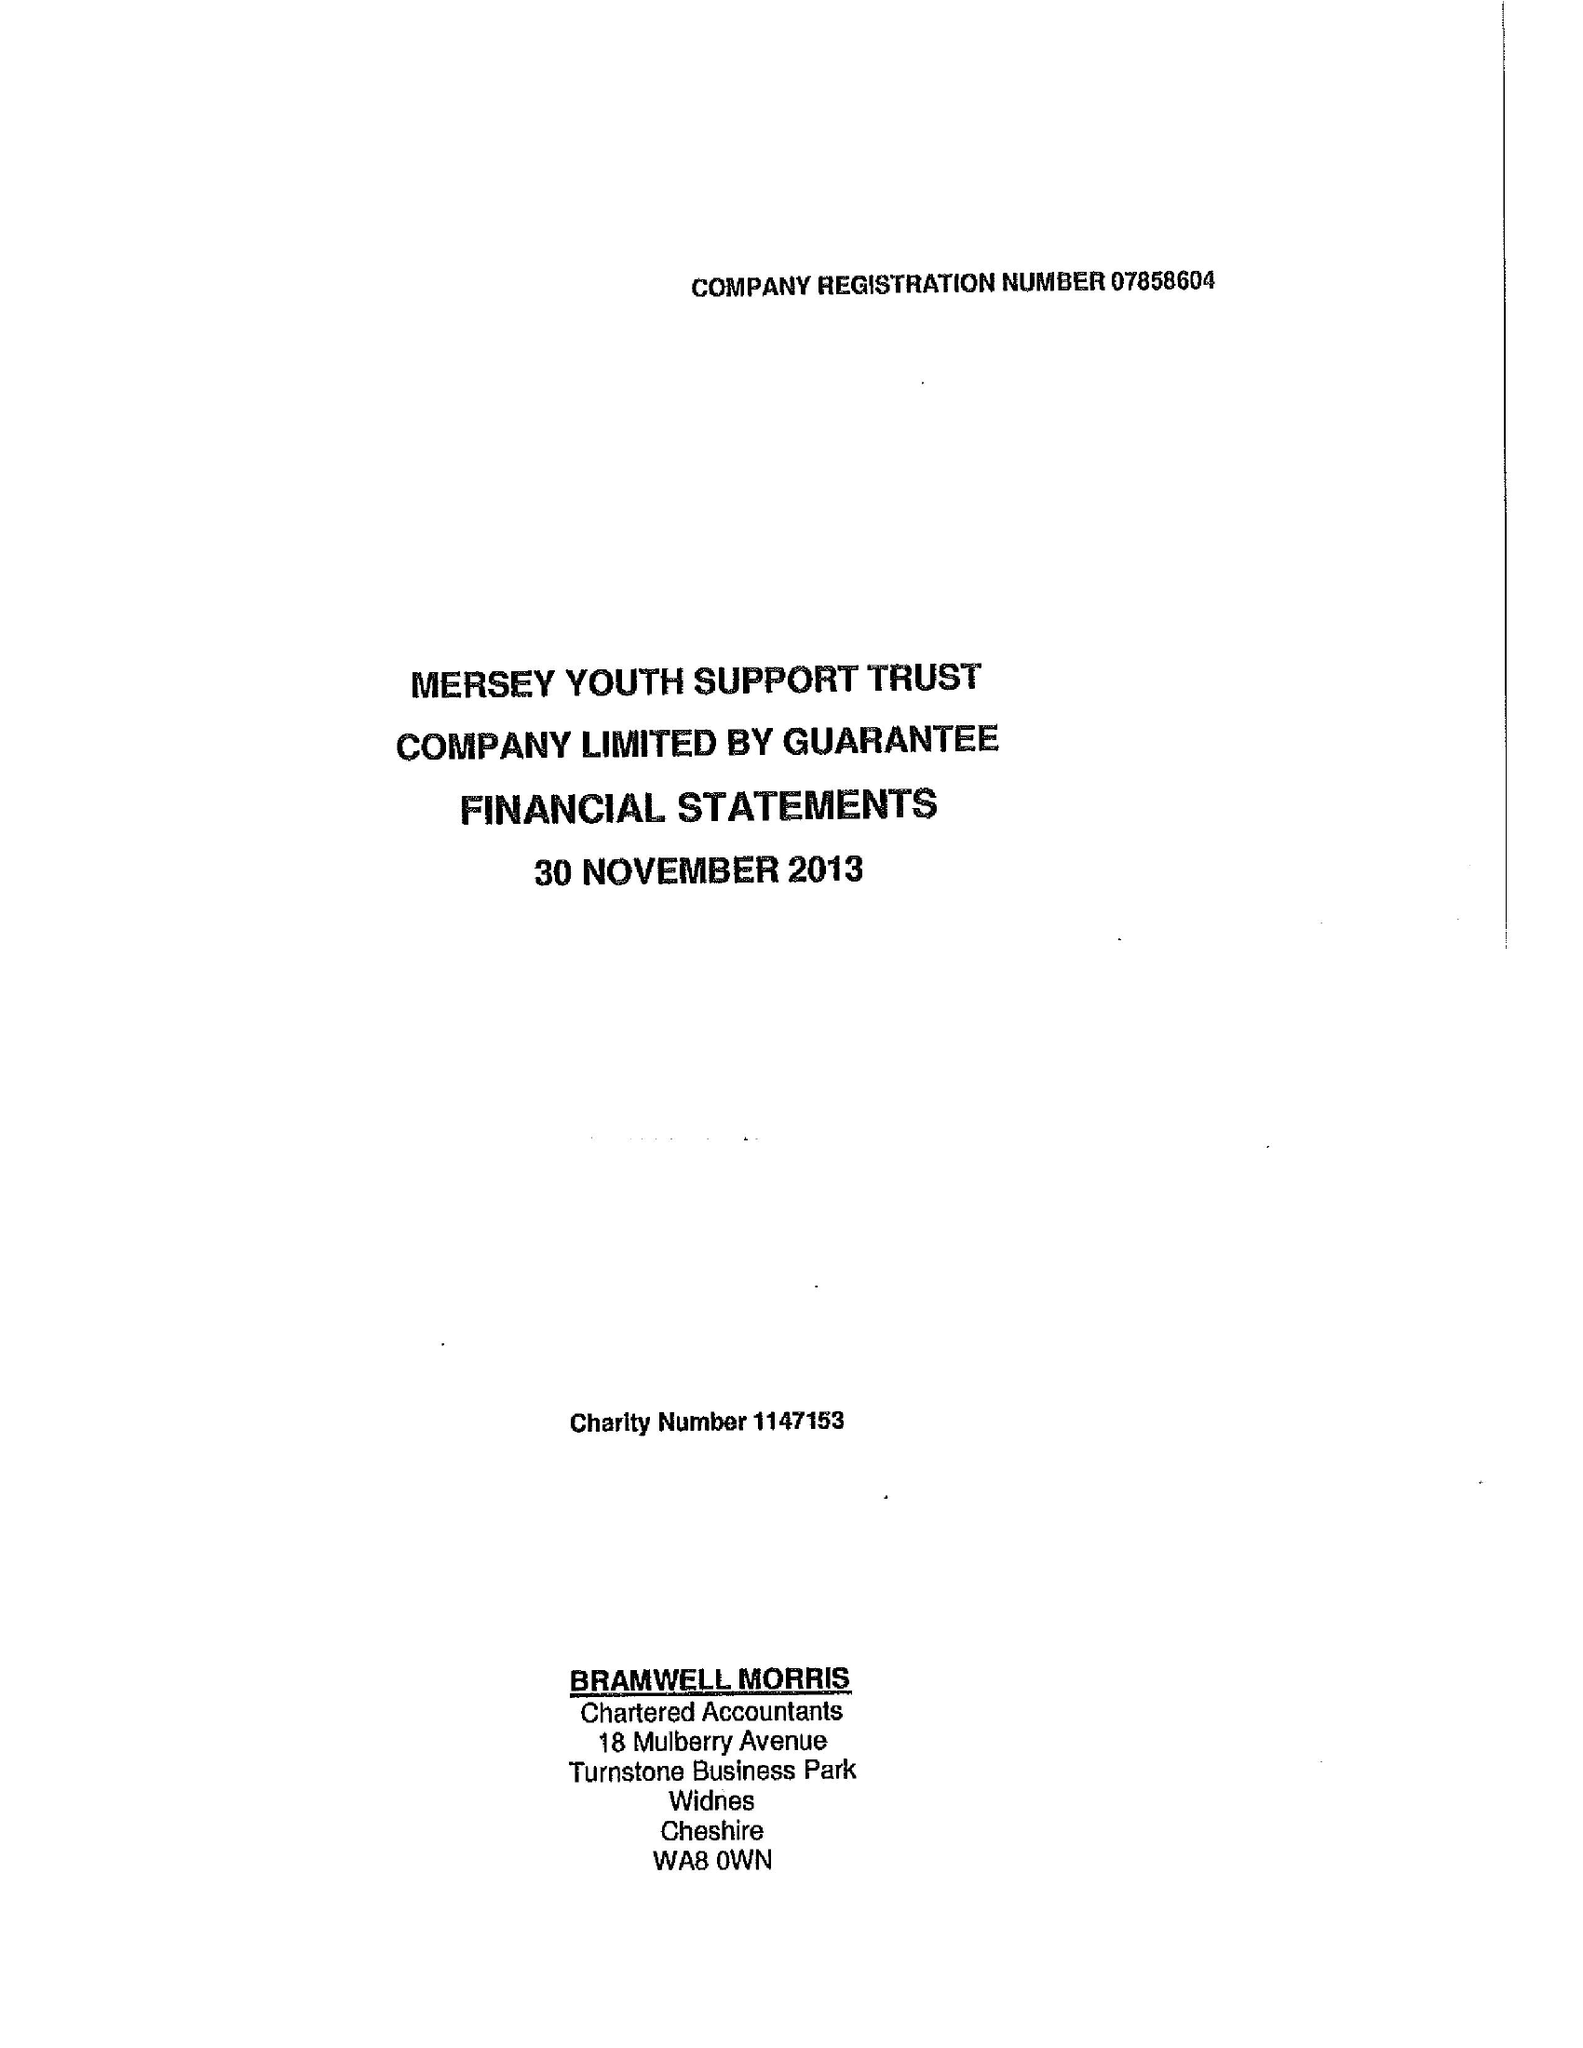What is the value for the address__post_town?
Answer the question using a single word or phrase. LIVERPOOL 